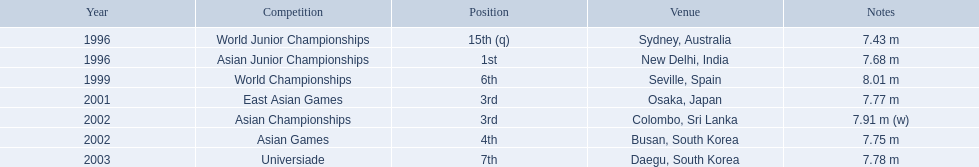What are all of the competitions? World Junior Championships, Asian Junior Championships, World Championships, East Asian Games, Asian Championships, Asian Games, Universiade. What was his positions in these competitions? 15th (q), 1st, 6th, 3rd, 3rd, 4th, 7th. And during which competition did he reach 1st place? Asian Junior Championships. 